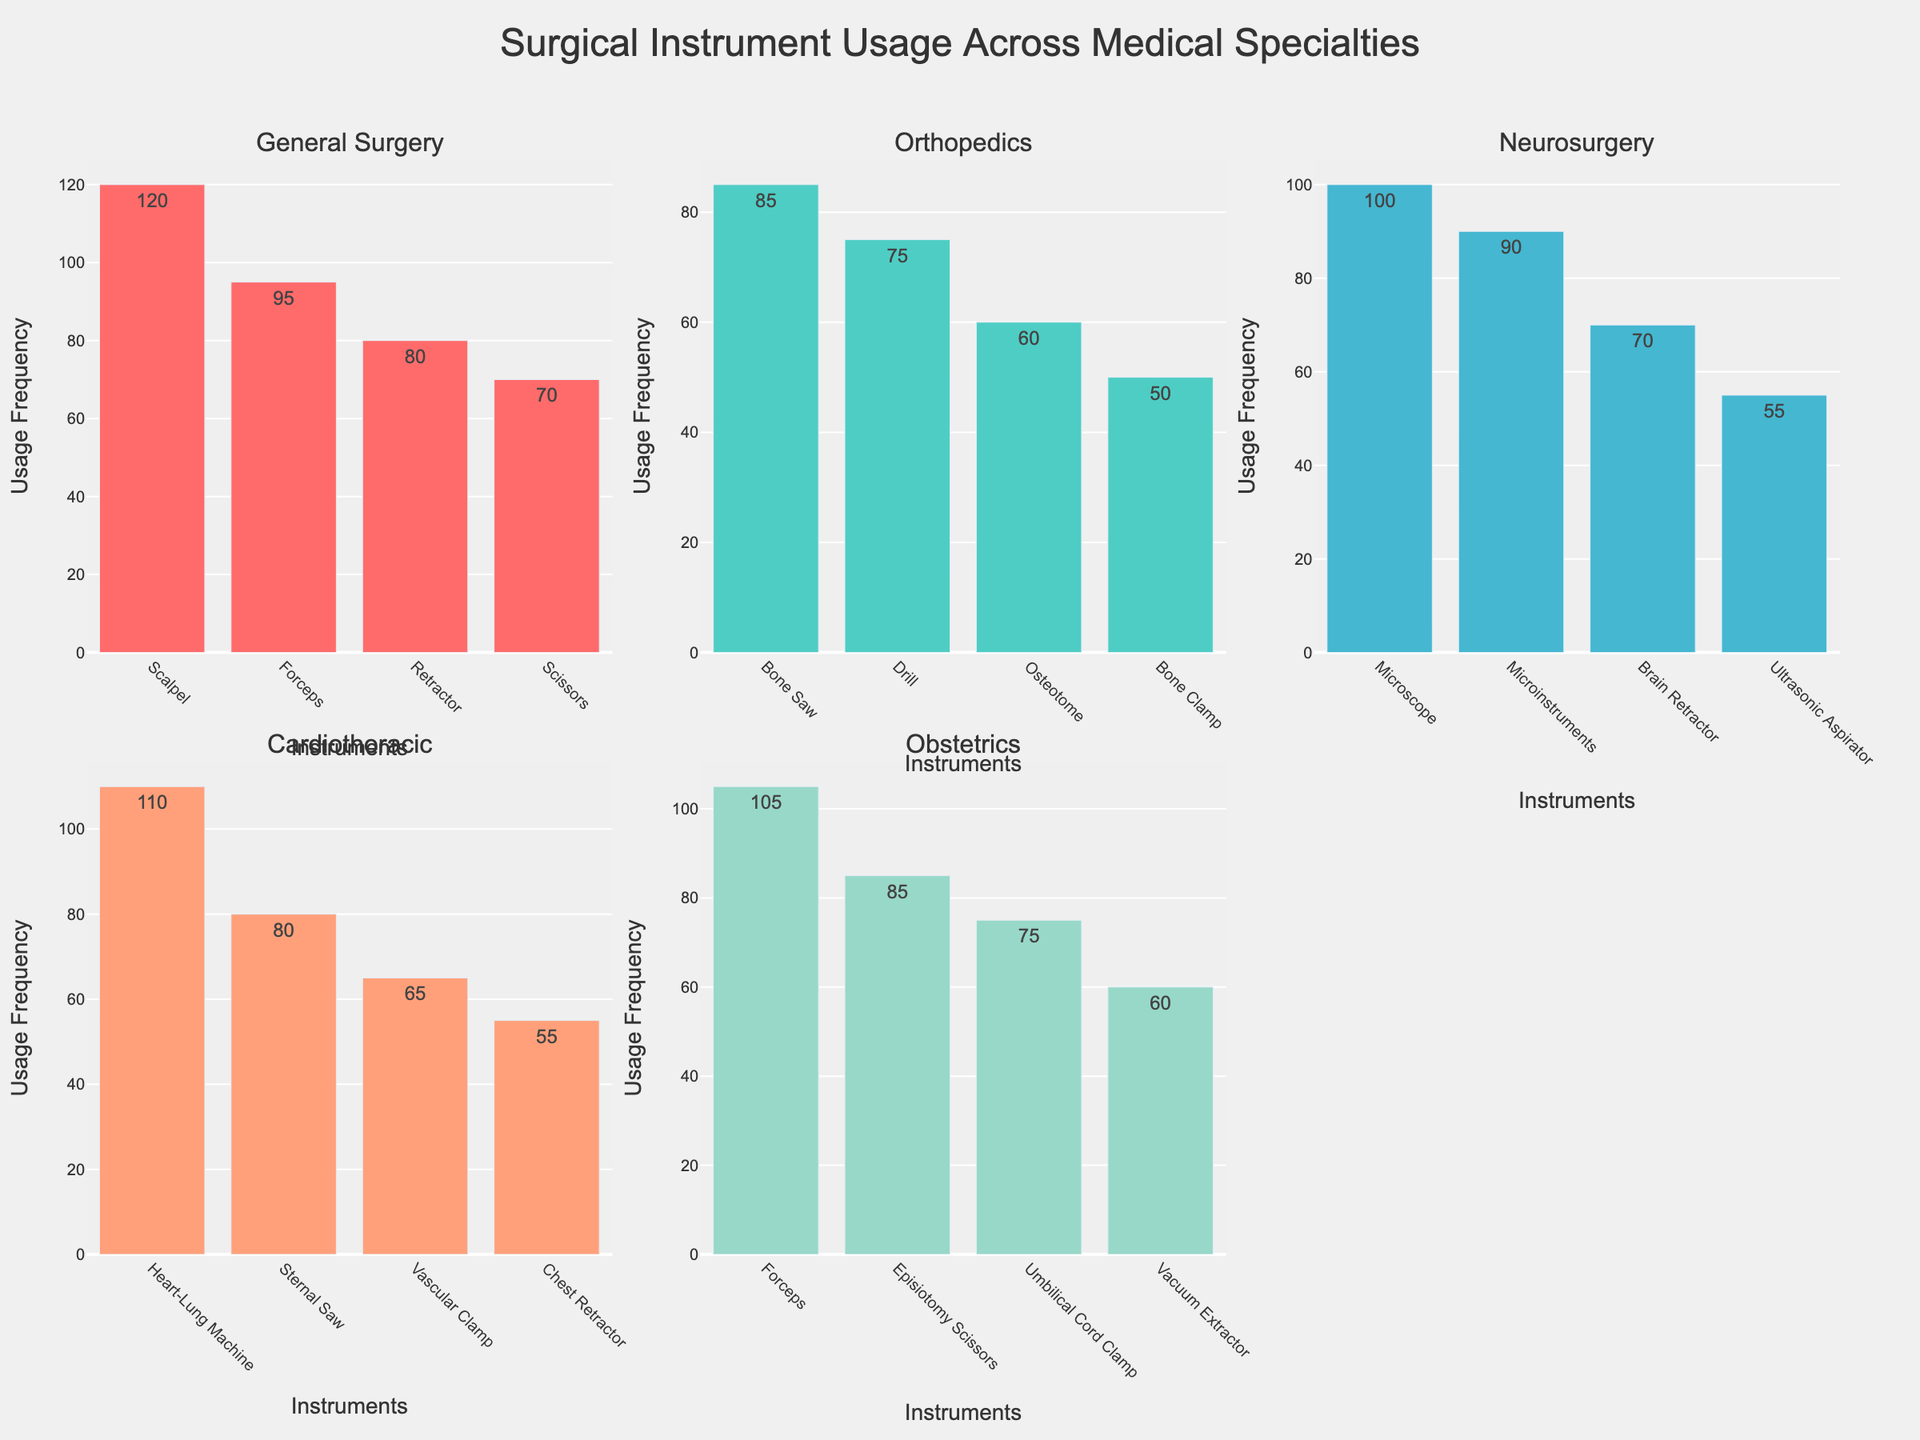How many specialty subplots are there in the figure? There are six subplots, each representing a different medical specialty. Visualize the plot titles: General Surgery, Orthopedics, Neurosurgery, Cardiothoracic surgery, and Obstetrics.
Answer: 5 What is the most frequently used instrument in General Surgery? In the General Surgery subplot, the bar with the highest value corresponds to the Scalpel, showing a usage frequency of 120.
Answer: Scalpel Which specialty uses Forceps, and what are their usage frequencies? Forceps are used in General Surgery and Obstetrics. In the General Surgery subplot, Forceps have a usage frequency of 95, and in the Obstetrics subplot, Forceps have a usage frequency of 105.
Answer: General Surgery: 95, Obstetrics: 105 What is the sum of usage frequencies of all instruments in Cardiothoracic surgery? By adding the usage frequencies of the instruments in the Cardiothoracic subplot: Heart-Lung Machine (110), Sternal Saw (80), Vascular Clamp (65), and Chest Retractor (55), the total is 110 + 80 + 65 + 55 = 310.
Answer: 310 Which specialty has the instrument with the lowest usage frequency, and what is that frequency? The specialty with the instrument having the lowest usage frequency is Orthopedics, where the Bone Clamp has a usage frequency of 50.
Answer: Orthopedics, 50 How does the usage frequency of the Microscope in Neurosurgery compare to the Microinstruments in the same specialty? In the Neurosurgery subplot, the Microscope has a usage frequency of 100, and the Microinstruments have a usage frequency of 90. Microscope usage is higher than that of the Microinstruments.
Answer: Microscope: 100, Microinstruments: 90 Which instrument has the highest usage frequency in the Obstetrics subplot and what is that frequency? The instrument with the highest usage frequency in the Obstetrics subplot is Forceps, with a frequency of 105.
Answer: Forceps, 105 What is the average usage frequency of the instruments in Orthopedics? By adding the usage frequencies of all Orthopedic instruments - Bone Saw (85), Drill (75), Osteotome (60), Bone Clamp (50) and dividing by the number of instruments (4), the average is (85 + 75 + 60 + 50) / 4 = 67.5.
Answer: 67.5 Which instruments are used in both General Surgery and Obstetrics? By checking the instruments listed under both General Surgery and Obstetrics, Forceps are used in both specialties.
Answer: Forceps What is the difference in frequency between the highest and lowest used instruments in Neurosurgery? In the Neurosurgery subplot, the highest frequency instrument is Microscope (100) and the lowest is the Ultrasonic Aspirator (55). The difference is 100 - 55 = 45.
Answer: 45 